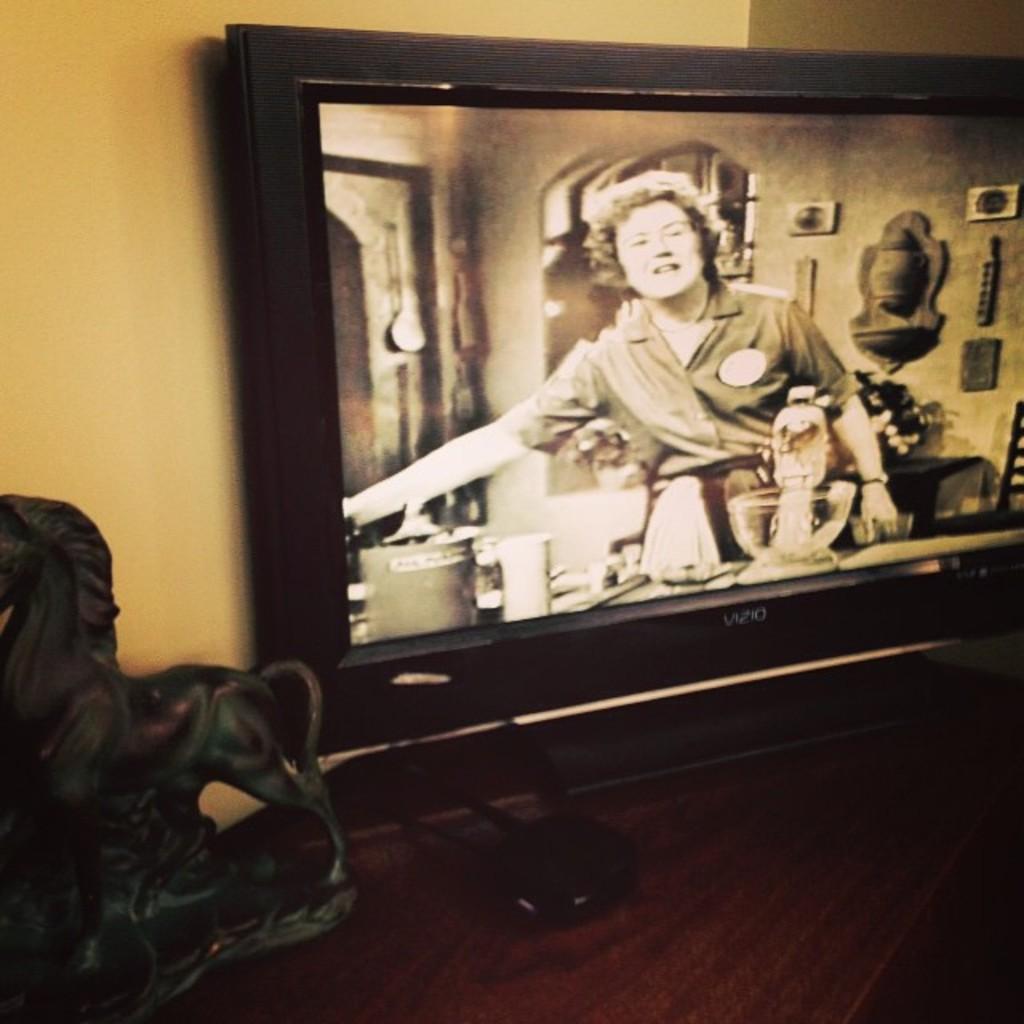Can you describe this image briefly? In this picture I can see there is a television placed on the wooden shelf and there is a woman standing. 